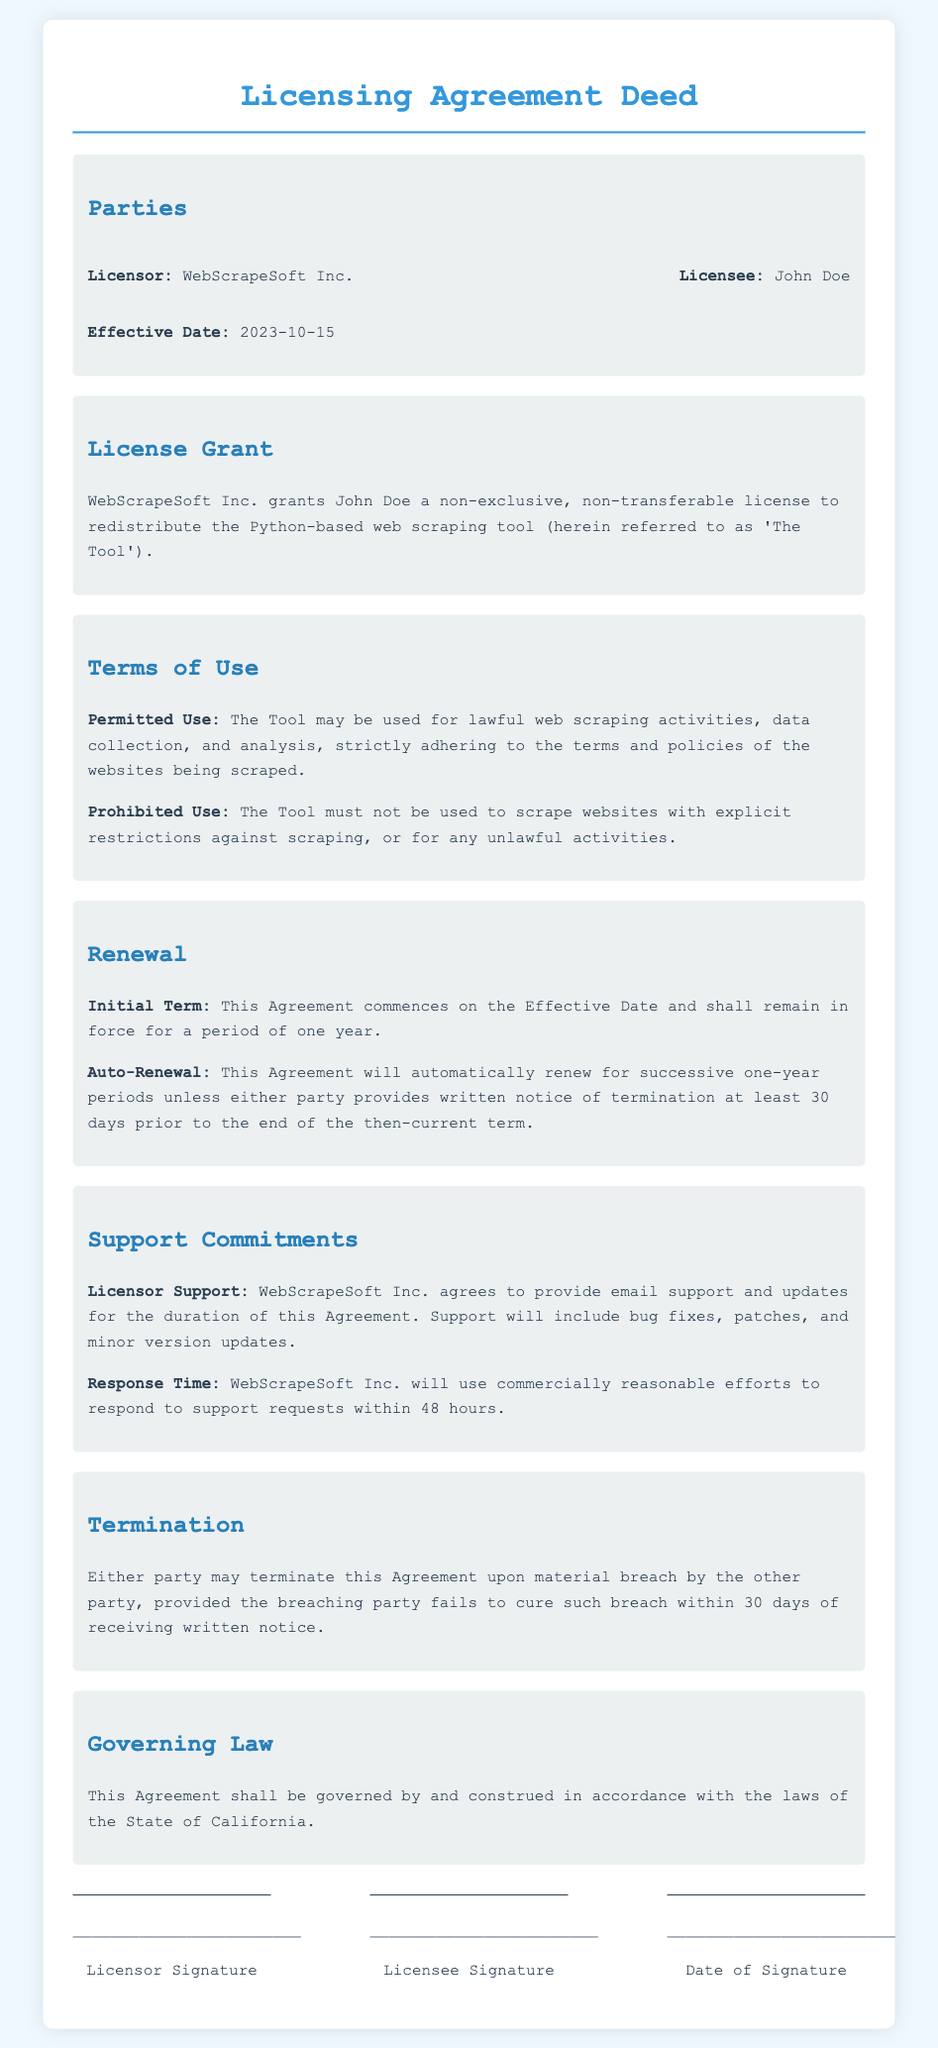what is the name of the licensor? The name of the licensor is stated in the document as "WebScrapeSoft Inc."
Answer: WebScrapeSoft Inc who is the licensee? The licensee mentioned in the document is "John Doe."
Answer: John Doe what is the effective date of the agreement? The effective date is clearly mentioned in the document to be "2023-10-15."
Answer: 2023-10-15 how long is the initial term of the agreement? The document specifies that the initial term is for a period of "one year."
Answer: one year what is the response time for support requests? The document states that "WebScrapeSoft Inc. will use commercially reasonable efforts to respond to support requests within 48 hours."
Answer: 48 hours when must notice of termination be provided? The document indicates that notice of termination must be given "at least 30 days prior" to the end of the current term.
Answer: at least 30 days prior what type of license is granted to the licensee? The document specifies that the license granted is a "non-exclusive, non-transferable license."
Answer: non-exclusive, non-transferable what kind of support does the licensor commit to provide? The document details that the licensor agrees to provide "email support and updates."
Answer: email support and updates under which jurisdiction is the agreement governed? The governing law stated in the document is "the laws of the State of California."
Answer: the laws of the State of California 